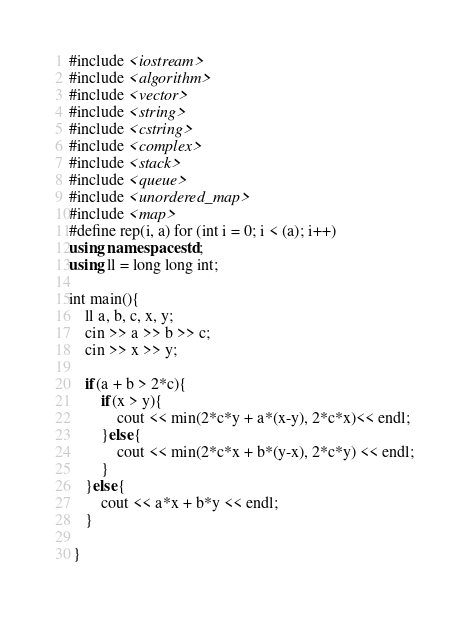Convert code to text. <code><loc_0><loc_0><loc_500><loc_500><_C++_>#include <iostream>
#include <algorithm>
#include <vector>
#include <string>
#include <cstring>
#include <complex>
#include <stack>
#include <queue>
#include <unordered_map>
#include <map>
#define rep(i, a) for (int i = 0; i < (a); i++)
using namespace std;
using ll = long long int;

int main(){
    ll a, b, c, x, y;
    cin >> a >> b >> c;
    cin >> x >> y;

    if(a + b > 2*c){
        if(x > y){
            cout << min(2*c*y + a*(x-y), 2*c*x)<< endl;
        }else{
            cout << min(2*c*x + b*(y-x), 2*c*y) << endl;
        }
    }else{
        cout << a*x + b*y << endl;
    }

 }
</code> 